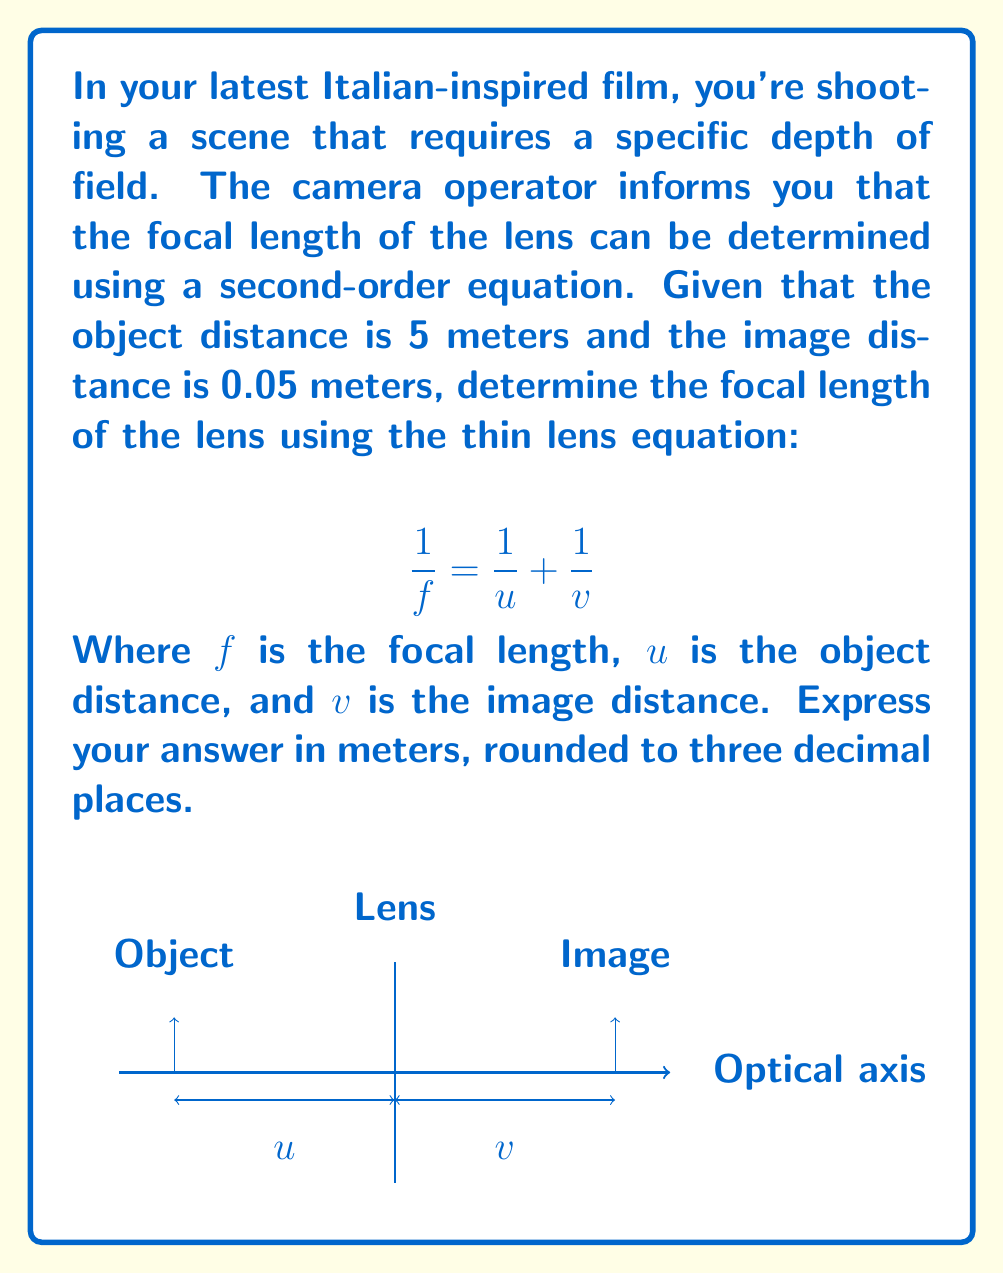Give your solution to this math problem. Let's solve this step-by-step using the thin lens equation:

1) We are given:
   $u = 5$ meters (object distance)
   $v = 0.05$ meters (image distance)

2) The thin lens equation is:
   $$\frac{1}{f} = \frac{1}{u} + \frac{1}{v}$$

3) Substituting the known values:
   $$\frac{1}{f} = \frac{1}{5} + \frac{1}{0.05}$$

4) Simplify the right side:
   $$\frac{1}{f} = 0.2 + 20 = 20.2$$

5) To solve for $f$, we take the reciprocal of both sides:
   $$f = \frac{1}{20.2}$$

6) Calculate the result:
   $$f \approx 0.04950495049505$$

7) Rounding to three decimal places:
   $$f \approx 0.050\text{ meters}$$
Answer: $0.050$ meters 